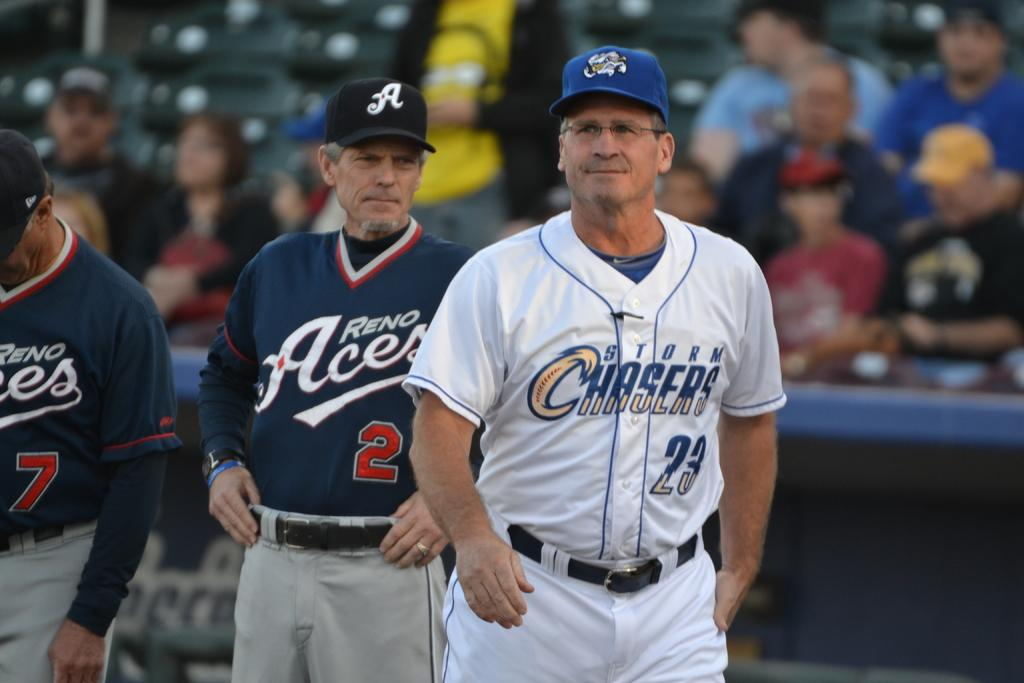<image>
Present a compact description of the photo's key features. Players from the Reno Acers and Storm Chasers on a baseball field. 